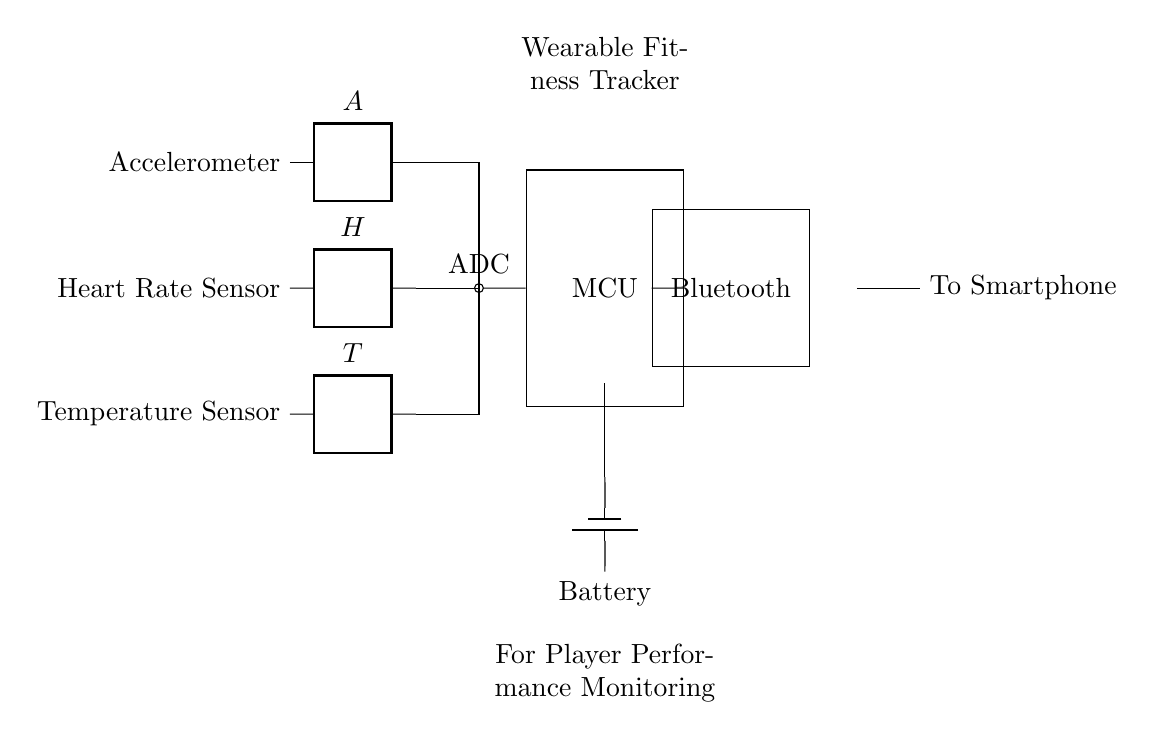What are the main components in the circuit? The main components are the accelerometer, heart rate sensor, temperature sensor, analog to digital converter, microcontroller, battery, Bluetooth module, and antenna. All of these elements are explicitly listed and can be identified visually in the diagram.
Answer: accelerometer, heart rate sensor, temperature sensor, ADC, microcontroller, battery, Bluetooth module, antenna What is the function of the ADC in this circuit? The analog to digital converter (ADC) is responsible for converting the analog signals from the sensors into digital data that can be processed by the microcontroller. This crucial step allows the system to interpret the analog readings from the sensors effectively.
Answer: converting analog signals to digital What connects the microcontroller to the Bluetooth module? The connection between the microcontroller and the Bluetooth module is a direct line. This line represents the communication channel through which the processed data is sent wirelessly to external devices, such as a smartphone.
Answer: a direct line Which component supplies power to the circuit? The component that supplies power is the battery. This is shown in the diagram, where energy is drawn to the microcontroller and other components from the battery, indicating that it is the main power source of the circuit.
Answer: battery How many sensors are present in this diagram? There are three sensors: an accelerometer, a heart rate sensor, and a temperature sensor. These can be distinctly identified in the circuit diagram, where each sensor is listed separately alongside their connections.
Answer: three What is the output of the Bluetooth module in this circuit? The output of the Bluetooth module is transmitted to an antenna, indicated in the diagram. This output facilitates wireless communication, allowing data to be sent from the wearable device to a smartphone or other receiving device.
Answer: to smartphone 